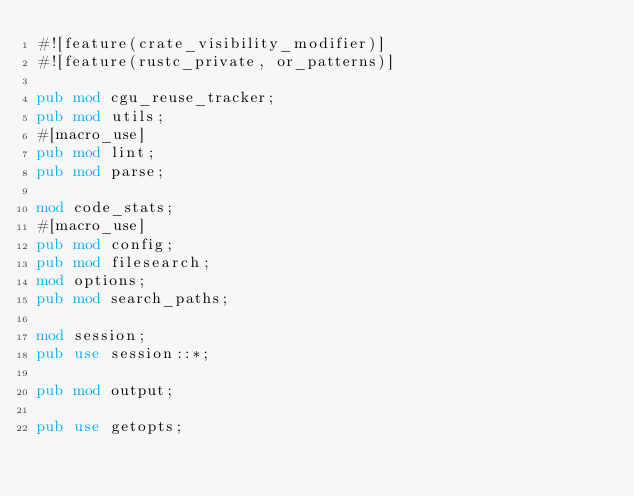<code> <loc_0><loc_0><loc_500><loc_500><_Rust_>#![feature(crate_visibility_modifier)]
#![feature(rustc_private, or_patterns)]

pub mod cgu_reuse_tracker;
pub mod utils;
#[macro_use]
pub mod lint;
pub mod parse;

mod code_stats;
#[macro_use]
pub mod config;
pub mod filesearch;
mod options;
pub mod search_paths;

mod session;
pub use session::*;

pub mod output;

pub use getopts;
</code> 